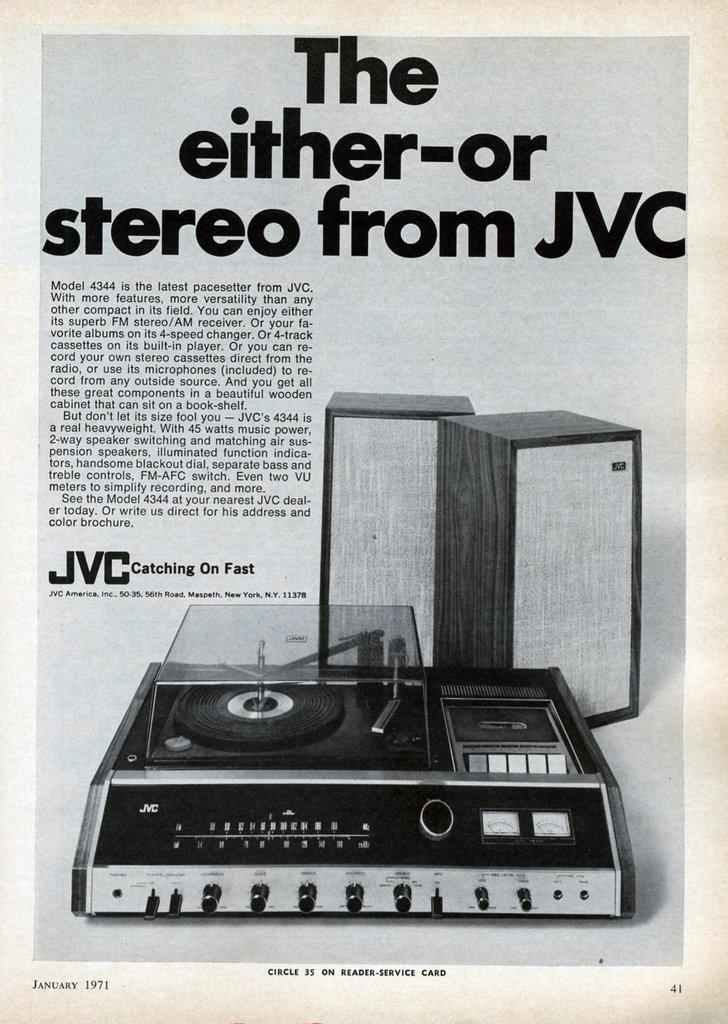What type of equipment is located at the bottom of the image? There is a sound system present at the bottom of the image. What can be seen at the top of the image? There is some text at the top of the image. What type of jelly is stored in the jar next to the sound system in the image? There is no jar or jelly present in the image; only the sound system and text are visible. What advice does the coach give to the team in the image? There is no coach or team present in the image; it only features a sound system and text. 